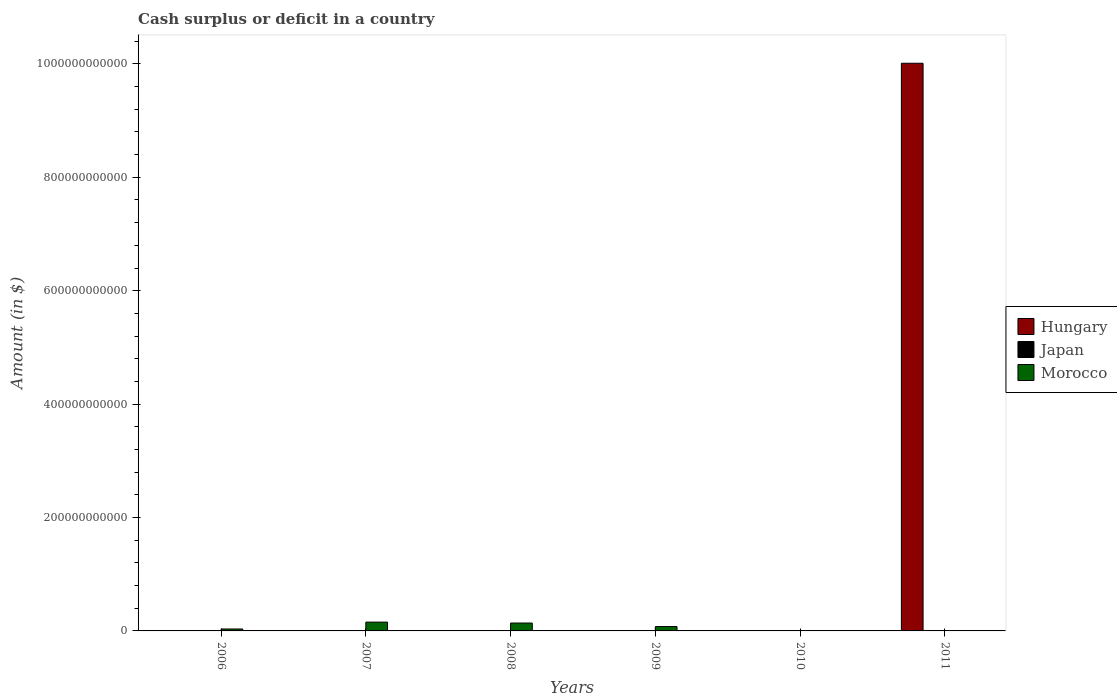How many different coloured bars are there?
Make the answer very short. 2. How many bars are there on the 6th tick from the left?
Your answer should be compact. 1. What is the amount of cash surplus or deficit in Hungary in 2009?
Give a very brief answer. 0. Across all years, what is the maximum amount of cash surplus or deficit in Morocco?
Ensure brevity in your answer.  1.55e+1. In which year was the amount of cash surplus or deficit in Morocco maximum?
Provide a succinct answer. 2007. What is the difference between the amount of cash surplus or deficit in Morocco in 2007 and that in 2009?
Your response must be concise. 7.87e+09. What is the difference between the amount of cash surplus or deficit in Japan in 2009 and the amount of cash surplus or deficit in Morocco in 2006?
Make the answer very short. -3.43e+09. What is the average amount of cash surplus or deficit in Morocco per year?
Keep it short and to the point. 6.76e+09. In how many years, is the amount of cash surplus or deficit in Hungary greater than 200000000000 $?
Ensure brevity in your answer.  1. What is the ratio of the amount of cash surplus or deficit in Morocco in 2008 to that in 2009?
Give a very brief answer. 1.81. What is the difference between the highest and the second highest amount of cash surplus or deficit in Morocco?
Ensure brevity in your answer.  1.64e+09. What is the difference between the highest and the lowest amount of cash surplus or deficit in Morocco?
Keep it short and to the point. 1.55e+1. Is it the case that in every year, the sum of the amount of cash surplus or deficit in Japan and amount of cash surplus or deficit in Hungary is greater than the amount of cash surplus or deficit in Morocco?
Offer a terse response. No. How many bars are there?
Offer a very short reply. 5. What is the difference between two consecutive major ticks on the Y-axis?
Provide a short and direct response. 2.00e+11. Are the values on the major ticks of Y-axis written in scientific E-notation?
Offer a terse response. No. Does the graph contain grids?
Your answer should be compact. No. Where does the legend appear in the graph?
Offer a terse response. Center right. How are the legend labels stacked?
Make the answer very short. Vertical. What is the title of the graph?
Your answer should be compact. Cash surplus or deficit in a country. What is the label or title of the X-axis?
Provide a succinct answer. Years. What is the label or title of the Y-axis?
Offer a very short reply. Amount (in $). What is the Amount (in $) in Japan in 2006?
Ensure brevity in your answer.  0. What is the Amount (in $) of Morocco in 2006?
Give a very brief answer. 3.43e+09. What is the Amount (in $) in Morocco in 2007?
Give a very brief answer. 1.55e+1. What is the Amount (in $) of Hungary in 2008?
Ensure brevity in your answer.  0. What is the Amount (in $) of Morocco in 2008?
Keep it short and to the point. 1.39e+1. What is the Amount (in $) in Morocco in 2009?
Make the answer very short. 7.67e+09. What is the Amount (in $) of Japan in 2010?
Provide a short and direct response. 0. What is the Amount (in $) of Morocco in 2010?
Make the answer very short. 0. What is the Amount (in $) of Hungary in 2011?
Make the answer very short. 1.00e+12. Across all years, what is the maximum Amount (in $) in Hungary?
Make the answer very short. 1.00e+12. Across all years, what is the maximum Amount (in $) of Morocco?
Ensure brevity in your answer.  1.55e+1. Across all years, what is the minimum Amount (in $) in Hungary?
Provide a succinct answer. 0. Across all years, what is the minimum Amount (in $) of Morocco?
Make the answer very short. 0. What is the total Amount (in $) in Hungary in the graph?
Give a very brief answer. 1.00e+12. What is the total Amount (in $) of Japan in the graph?
Your answer should be compact. 0. What is the total Amount (in $) in Morocco in the graph?
Make the answer very short. 4.05e+1. What is the difference between the Amount (in $) of Morocco in 2006 and that in 2007?
Make the answer very short. -1.21e+1. What is the difference between the Amount (in $) in Morocco in 2006 and that in 2008?
Provide a succinct answer. -1.05e+1. What is the difference between the Amount (in $) in Morocco in 2006 and that in 2009?
Make the answer very short. -4.24e+09. What is the difference between the Amount (in $) in Morocco in 2007 and that in 2008?
Offer a very short reply. 1.64e+09. What is the difference between the Amount (in $) of Morocco in 2007 and that in 2009?
Offer a terse response. 7.87e+09. What is the difference between the Amount (in $) of Morocco in 2008 and that in 2009?
Your answer should be compact. 6.23e+09. What is the average Amount (in $) in Hungary per year?
Make the answer very short. 1.67e+11. What is the average Amount (in $) of Japan per year?
Your response must be concise. 0. What is the average Amount (in $) in Morocco per year?
Ensure brevity in your answer.  6.76e+09. What is the ratio of the Amount (in $) of Morocco in 2006 to that in 2007?
Give a very brief answer. 0.22. What is the ratio of the Amount (in $) of Morocco in 2006 to that in 2008?
Keep it short and to the point. 0.25. What is the ratio of the Amount (in $) in Morocco in 2006 to that in 2009?
Your answer should be very brief. 0.45. What is the ratio of the Amount (in $) of Morocco in 2007 to that in 2008?
Make the answer very short. 1.12. What is the ratio of the Amount (in $) of Morocco in 2007 to that in 2009?
Provide a succinct answer. 2.03. What is the ratio of the Amount (in $) of Morocco in 2008 to that in 2009?
Provide a short and direct response. 1.81. What is the difference between the highest and the second highest Amount (in $) of Morocco?
Give a very brief answer. 1.64e+09. What is the difference between the highest and the lowest Amount (in $) of Hungary?
Offer a terse response. 1.00e+12. What is the difference between the highest and the lowest Amount (in $) of Morocco?
Your answer should be compact. 1.55e+1. 